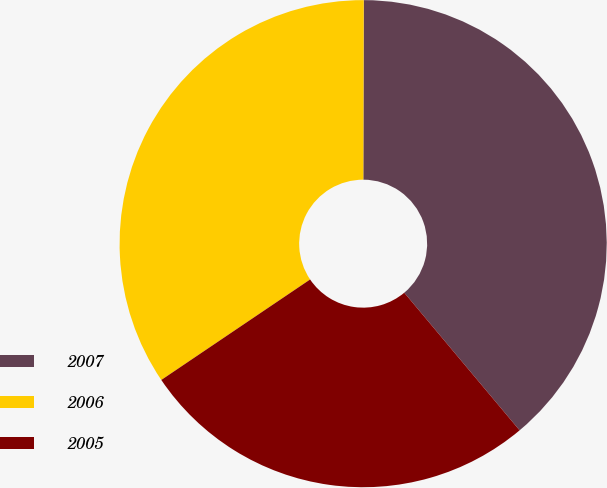Convert chart to OTSL. <chart><loc_0><loc_0><loc_500><loc_500><pie_chart><fcel>2007<fcel>2006<fcel>2005<nl><fcel>38.86%<fcel>34.49%<fcel>26.65%<nl></chart> 